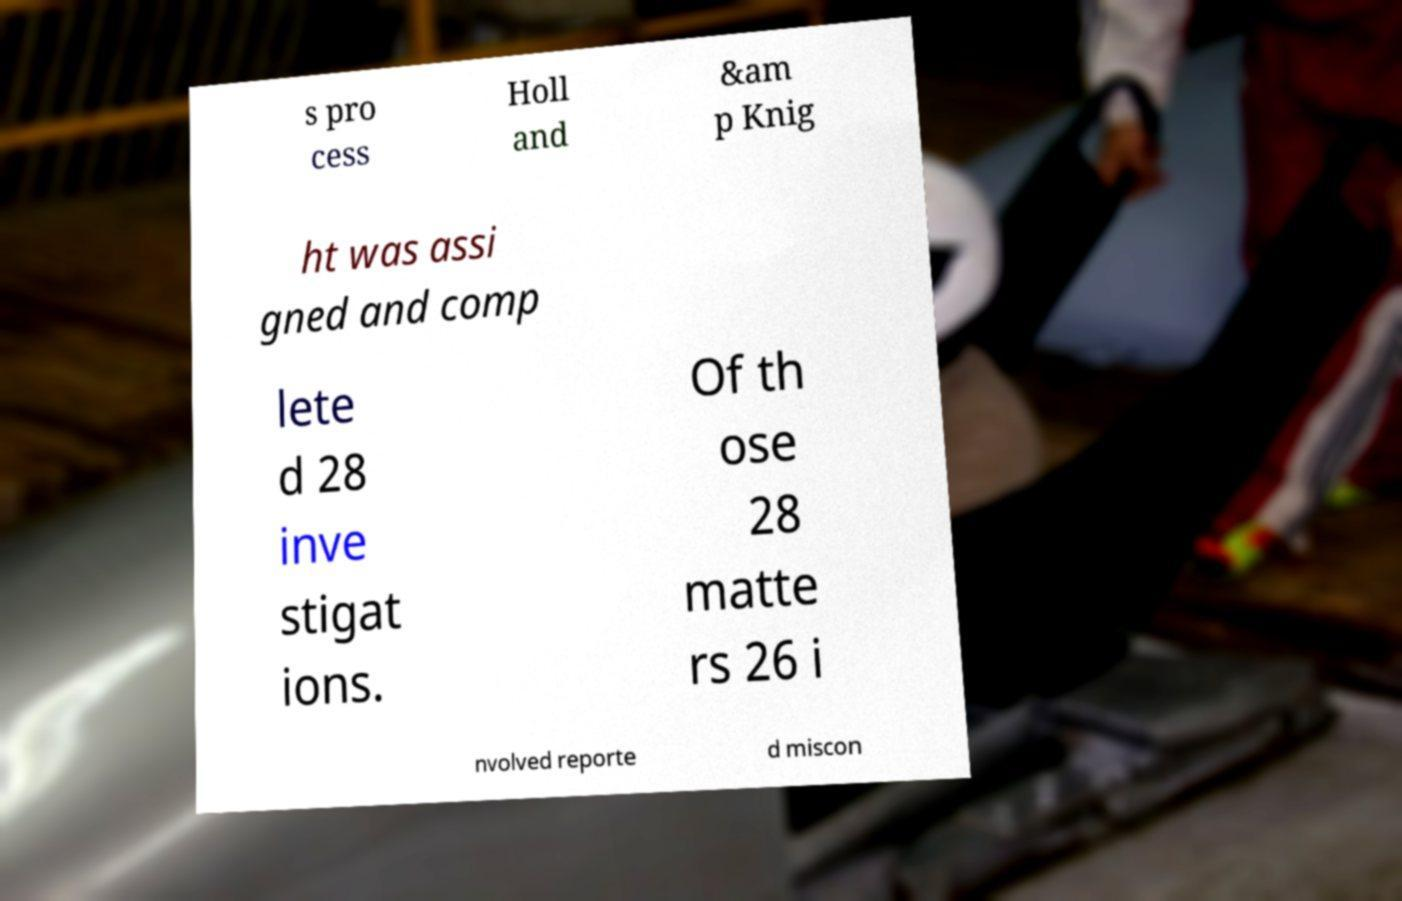Could you assist in decoding the text presented in this image and type it out clearly? s pro cess Holl and &am p Knig ht was assi gned and comp lete d 28 inve stigat ions. Of th ose 28 matte rs 26 i nvolved reporte d miscon 